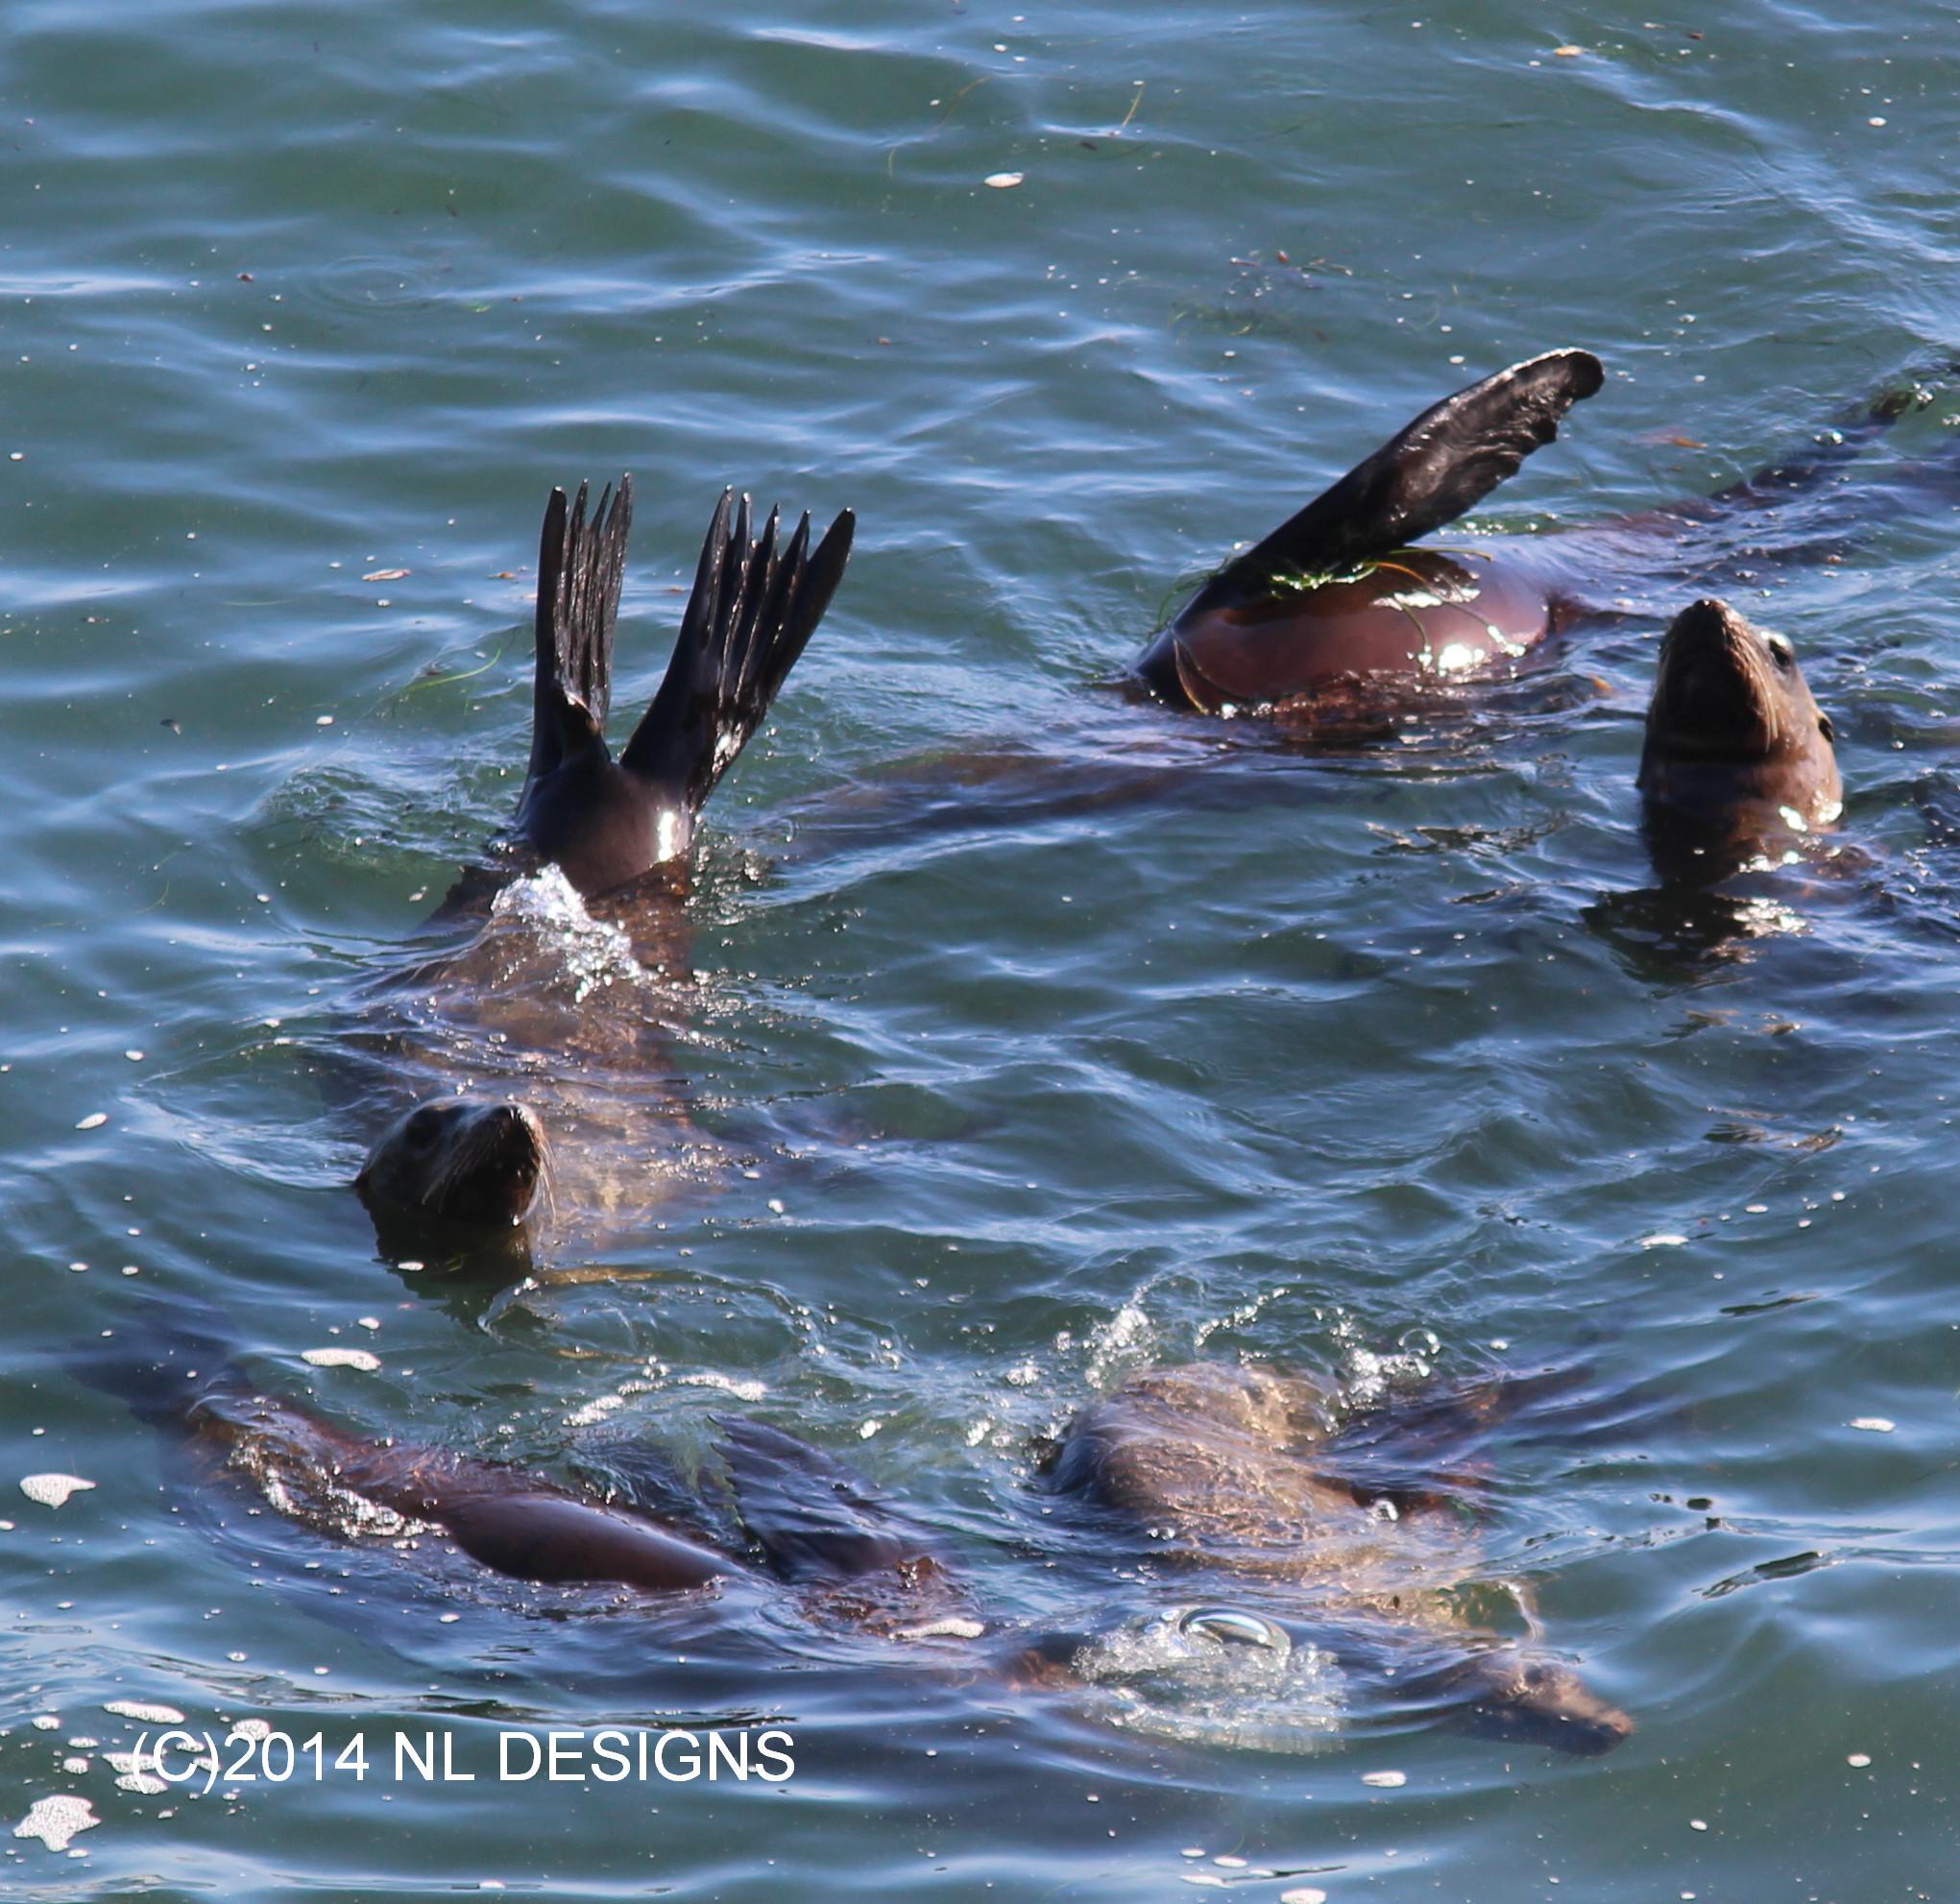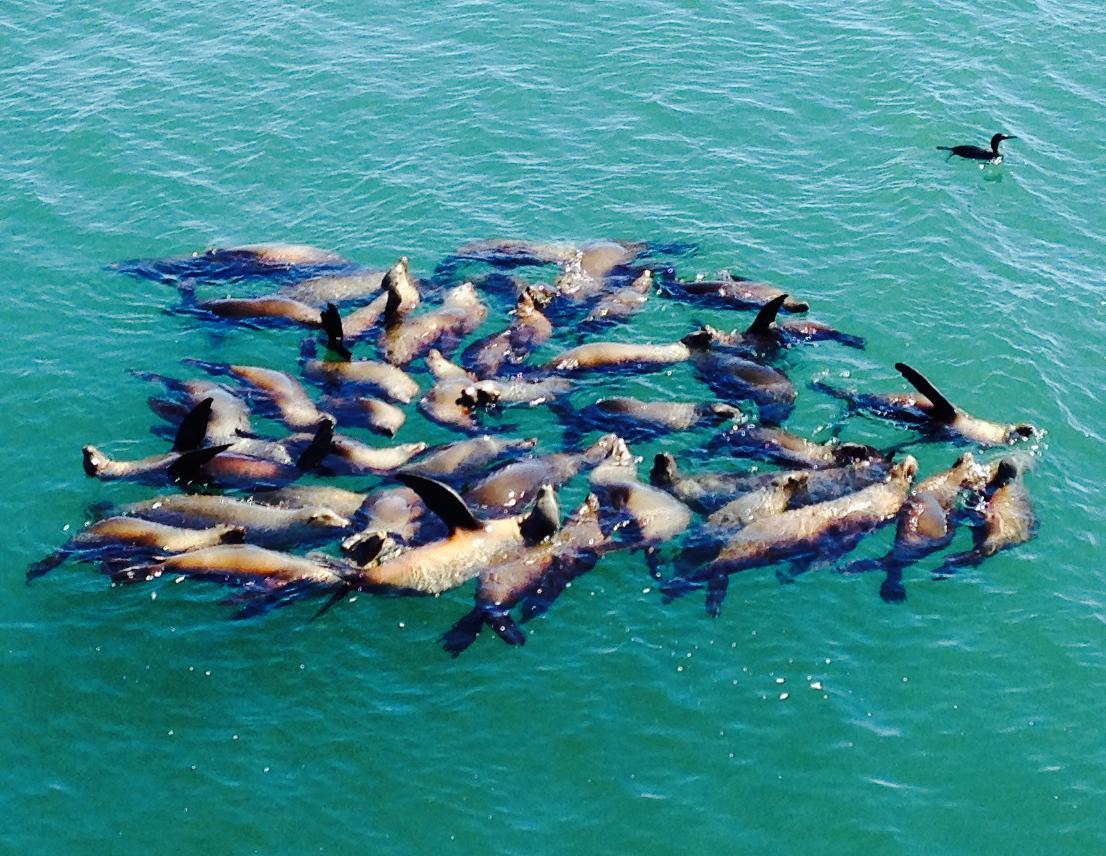The first image is the image on the left, the second image is the image on the right. Assess this claim about the two images: "There are sea lions resting on the narrow beams under the pier.". Correct or not? Answer yes or no. No. The first image is the image on the left, the second image is the image on the right. Evaluate the accuracy of this statement regarding the images: "The left image shows at least one seal balanced on a cross beam near vertical poles in water beneath a pier.". Is it true? Answer yes or no. No. 